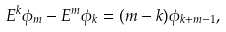<formula> <loc_0><loc_0><loc_500><loc_500>E ^ { k } \phi _ { m } - E ^ { m } \phi _ { k } = ( m - k ) \phi _ { k + m - 1 } ,</formula> 